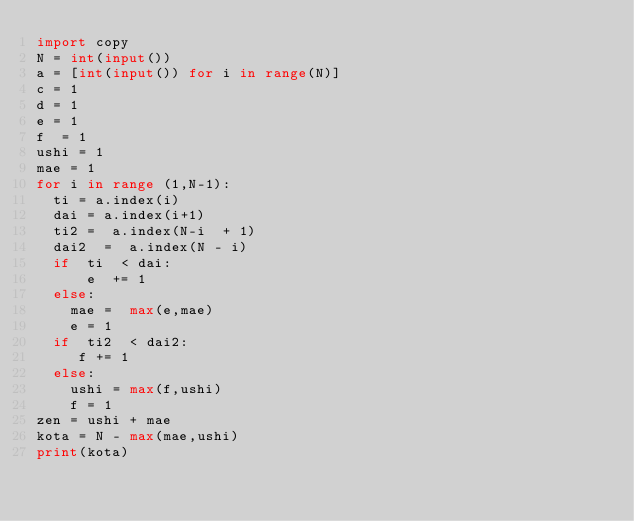<code> <loc_0><loc_0><loc_500><loc_500><_Python_>import copy
N = int(input())
a = [int(input()) for i in range(N)]
c = 1
d = 1
e = 1
f  = 1
ushi = 1
mae = 1
for i in range (1,N-1):
  ti = a.index(i)
  dai = a.index(i+1)
  ti2 =  a.index(N-i  + 1)
  dai2  =  a.index(N - i)
  if  ti  < dai:
      e  += 1
  else:
    mae =  max(e,mae)
    e = 1
  if  ti2  < dai2:
     f += 1
  else:
    ushi = max(f,ushi)
    f = 1
zen = ushi + mae
kota = N - max(mae,ushi)
print(kota)</code> 